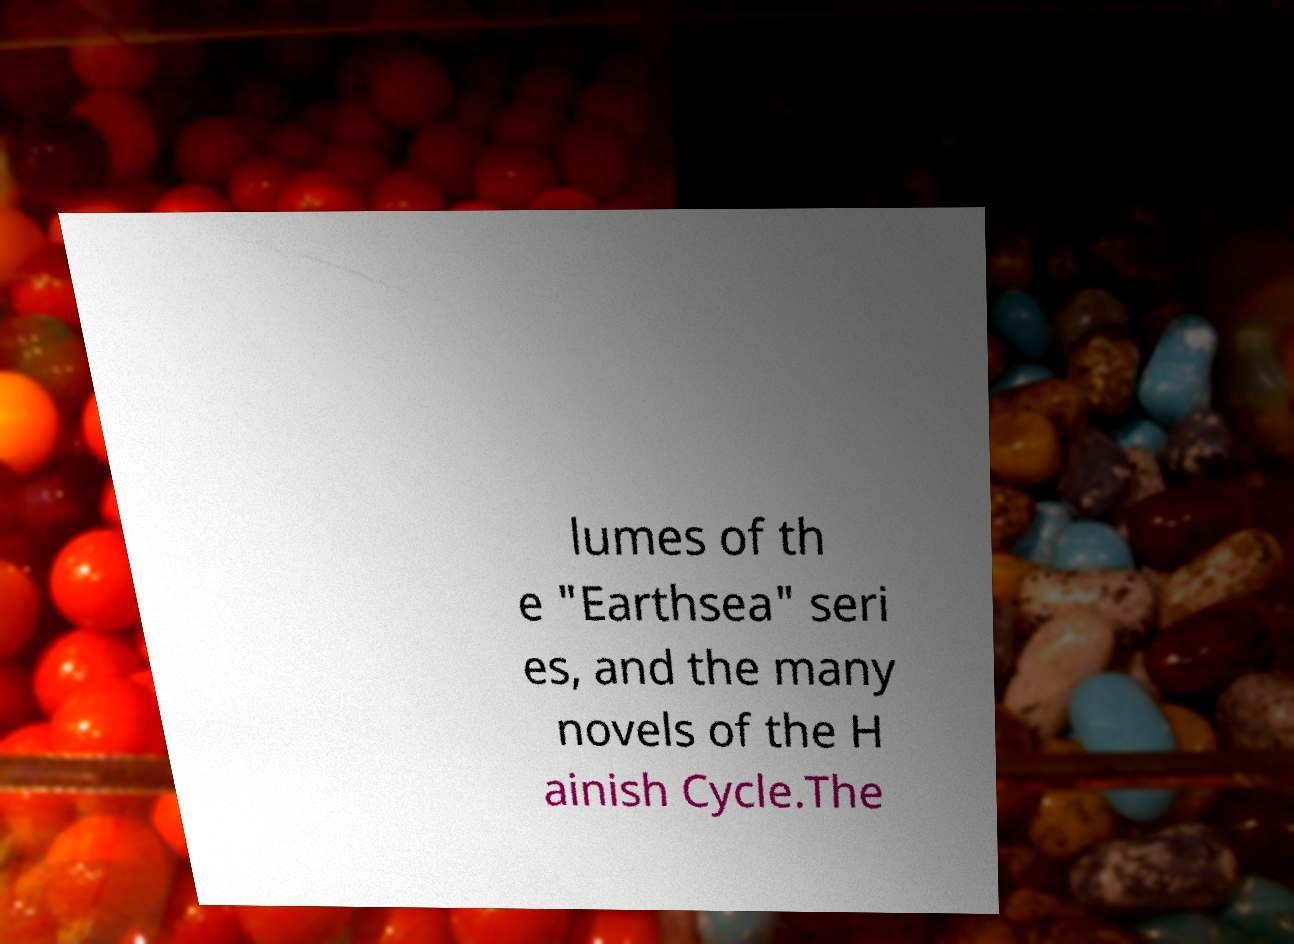For documentation purposes, I need the text within this image transcribed. Could you provide that? lumes of th e "Earthsea" seri es, and the many novels of the H ainish Cycle.The 